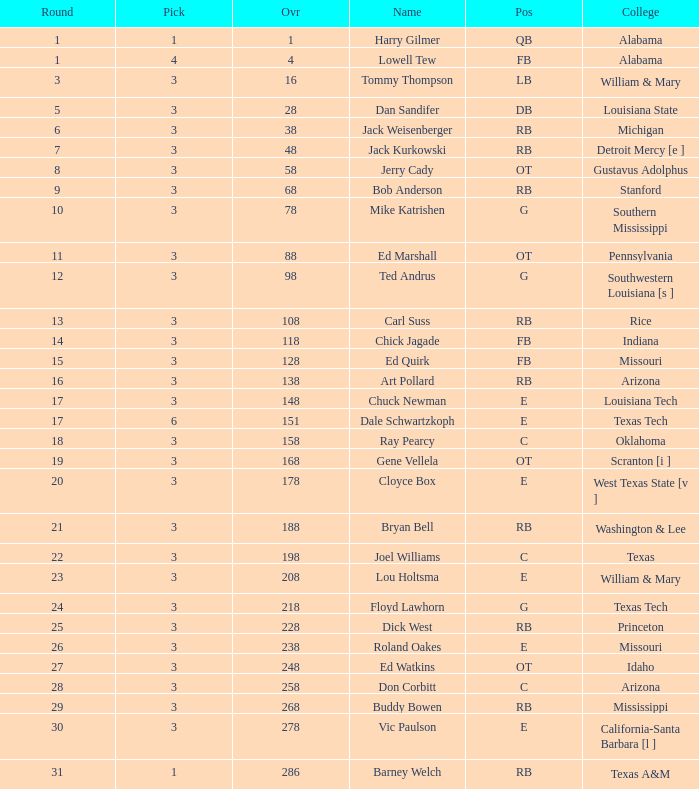How much Overall has a Name of bob anderson? 1.0. 